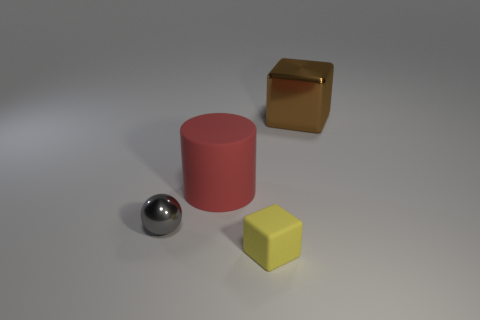Add 3 large brown cubes. How many objects exist? 7 Subtract all spheres. How many objects are left? 3 Add 4 brown metal spheres. How many brown metal spheres exist? 4 Subtract 0 purple cubes. How many objects are left? 4 Subtract all large gray shiny balls. Subtract all large brown cubes. How many objects are left? 3 Add 4 big cylinders. How many big cylinders are left? 5 